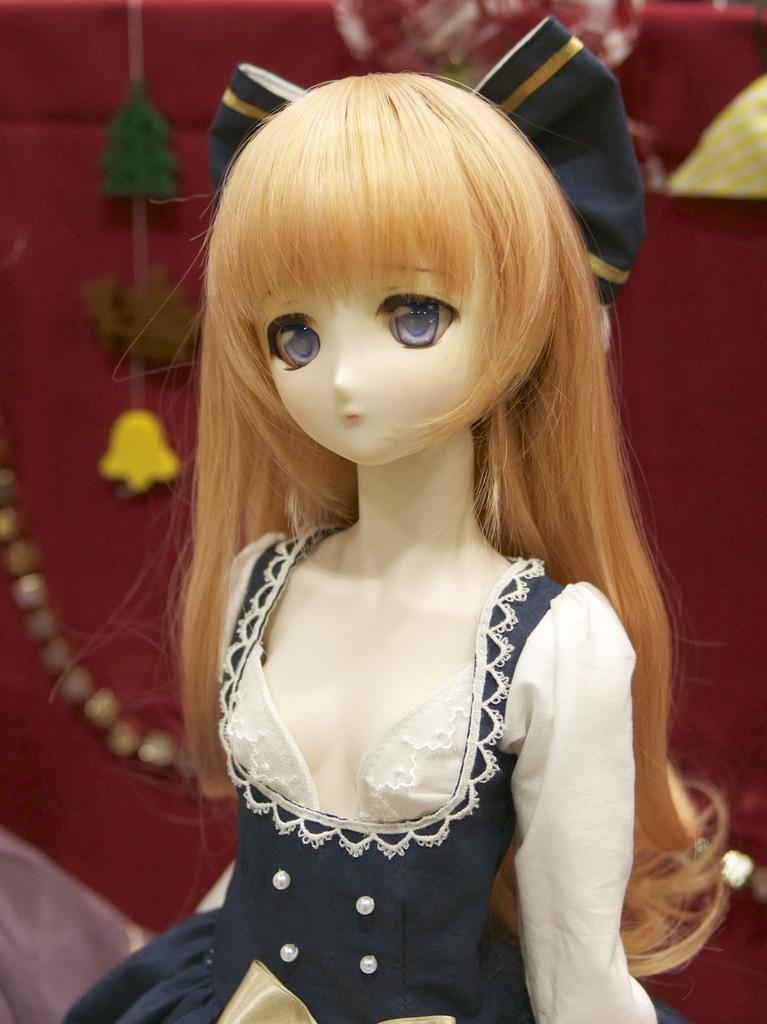What is the main subject of the image? There is a doll in the image. What can be observed about the doll's appearance? The doll has clothes on it. How many oranges are being held by the goat in the image? There is no goat or oranges present in the image; it features a doll with clothes on it. 